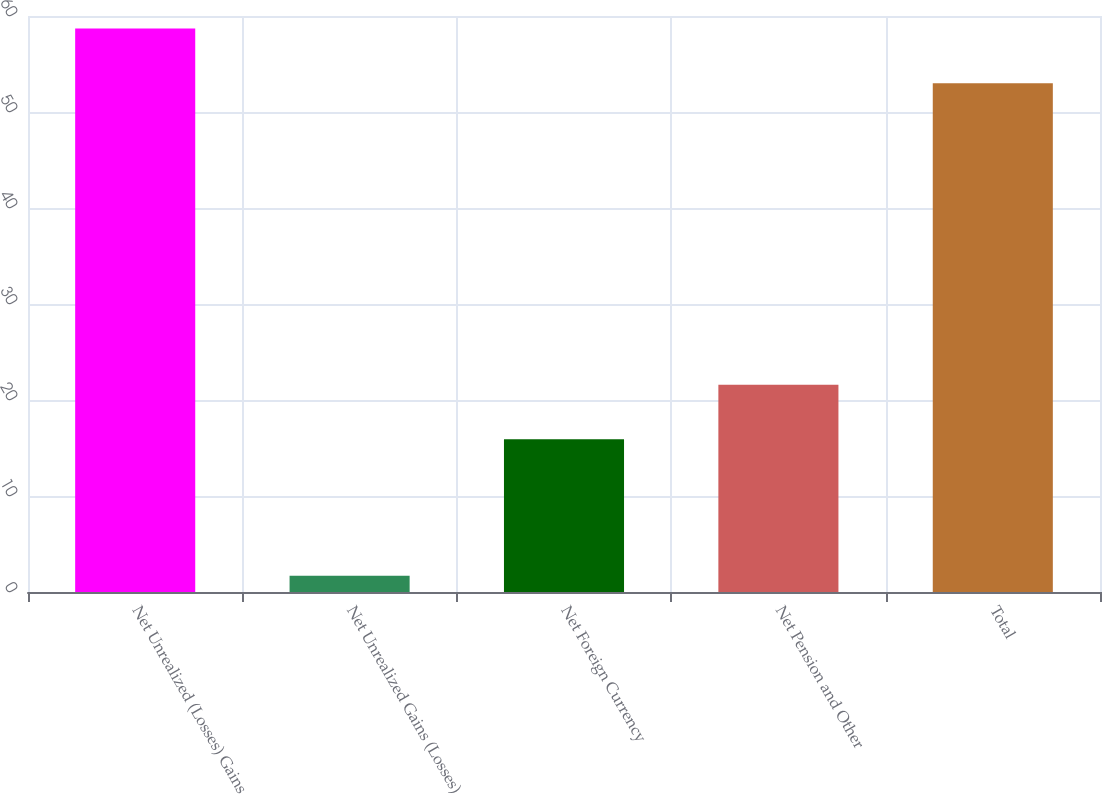Convert chart. <chart><loc_0><loc_0><loc_500><loc_500><bar_chart><fcel>Net Unrealized (Losses) Gains<fcel>Net Unrealized Gains (Losses)<fcel>Net Foreign Currency<fcel>Net Pension and Other<fcel>Total<nl><fcel>58.69<fcel>1.7<fcel>15.9<fcel>21.59<fcel>53<nl></chart> 